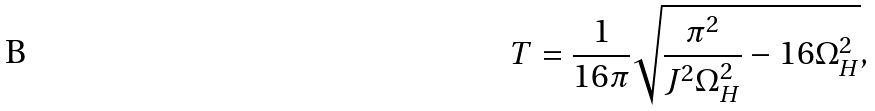Convert formula to latex. <formula><loc_0><loc_0><loc_500><loc_500>T = \frac { 1 } { 1 6 \pi } \sqrt { \frac { \pi ^ { 2 } } { J ^ { 2 } \Omega _ { H } ^ { 2 } } - 1 6 \Omega _ { H } ^ { 2 } } ,</formula> 